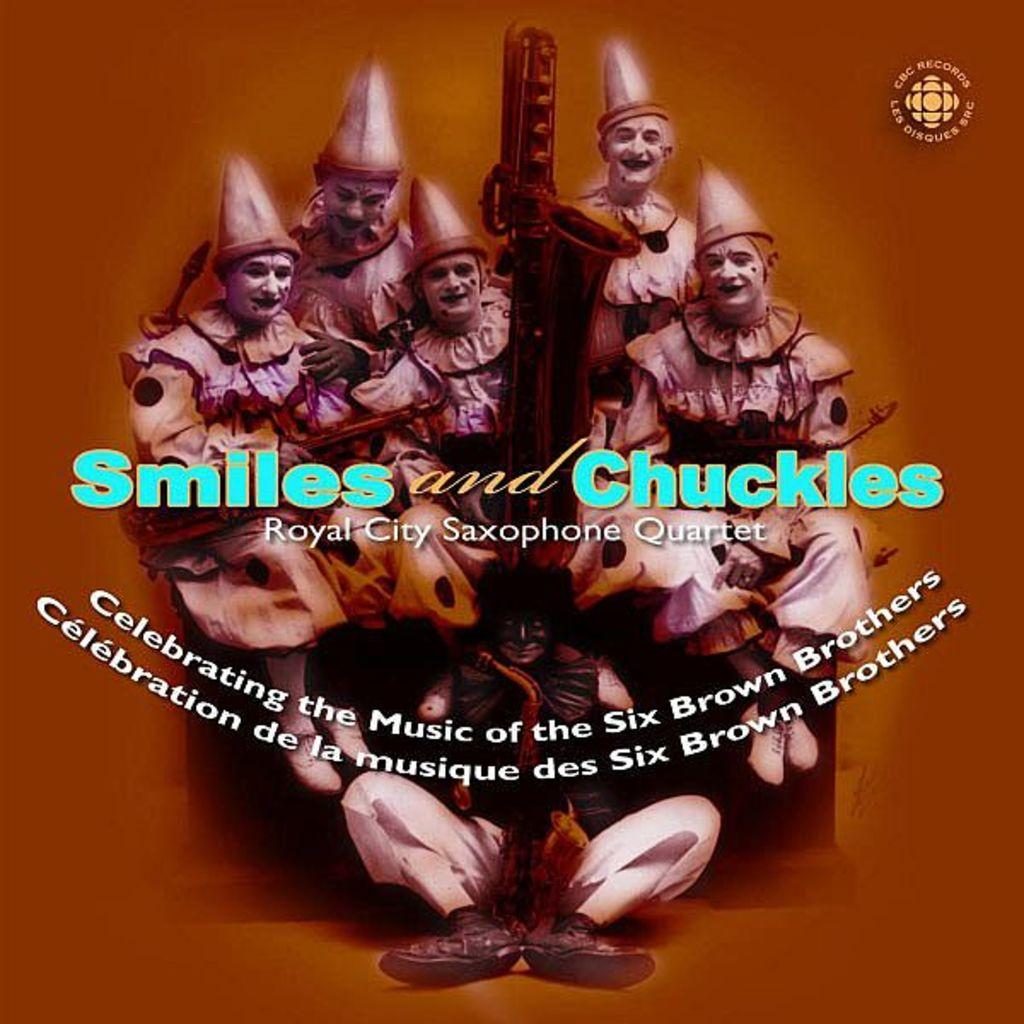How many people are in the image? There is a group of persons in the image. What are the persons in the image doing? The persons are sitting together. What can be observed about the attire of the persons in the image? The persons are wearing different costumes. Is there any text present in the image? Yes, there is some text in the image. What type of pickle is being used as a prop in the image? There is no pickle present in the image. Can you describe the grass in the image? There is no grass present in the image. 